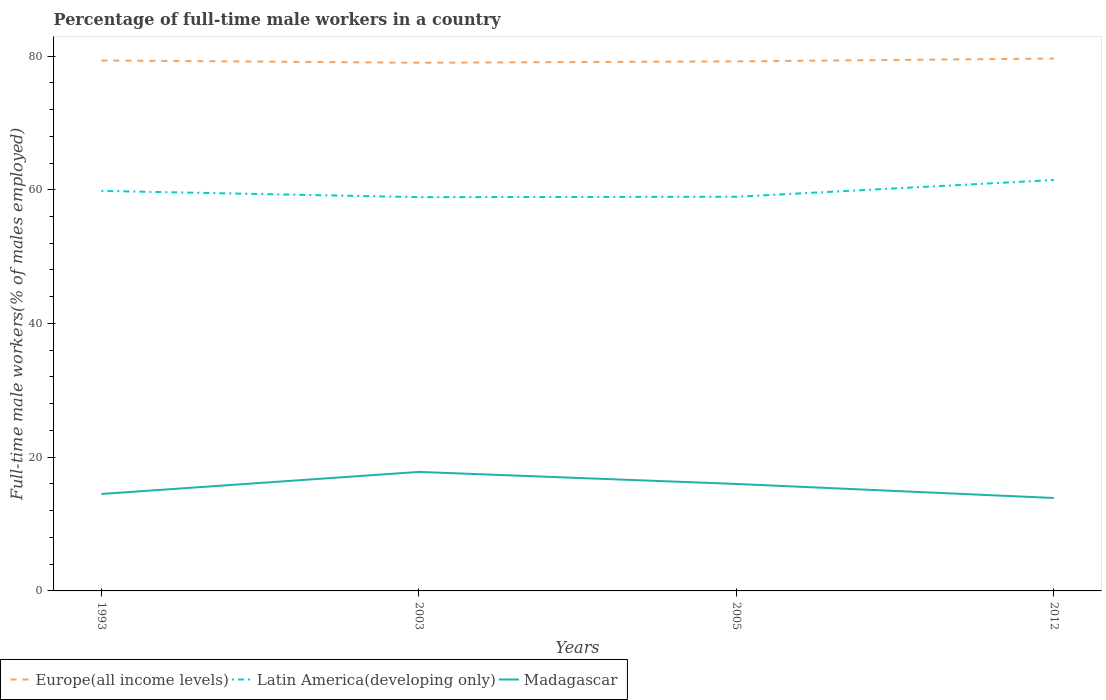How many different coloured lines are there?
Provide a succinct answer. 3. Across all years, what is the maximum percentage of full-time male workers in Europe(all income levels)?
Provide a succinct answer. 79. In which year was the percentage of full-time male workers in Madagascar maximum?
Keep it short and to the point. 2012. What is the total percentage of full-time male workers in Latin America(developing only) in the graph?
Keep it short and to the point. -2.56. What is the difference between the highest and the second highest percentage of full-time male workers in Madagascar?
Give a very brief answer. 3.9. What is the difference between the highest and the lowest percentage of full-time male workers in Europe(all income levels)?
Ensure brevity in your answer.  2. Where does the legend appear in the graph?
Make the answer very short. Bottom left. What is the title of the graph?
Your response must be concise. Percentage of full-time male workers in a country. Does "Vanuatu" appear as one of the legend labels in the graph?
Your answer should be very brief. No. What is the label or title of the X-axis?
Make the answer very short. Years. What is the label or title of the Y-axis?
Your response must be concise. Full-time male workers(% of males employed). What is the Full-time male workers(% of males employed) in Europe(all income levels) in 1993?
Give a very brief answer. 79.34. What is the Full-time male workers(% of males employed) of Latin America(developing only) in 1993?
Ensure brevity in your answer.  59.83. What is the Full-time male workers(% of males employed) of Europe(all income levels) in 2003?
Ensure brevity in your answer.  79. What is the Full-time male workers(% of males employed) of Latin America(developing only) in 2003?
Provide a short and direct response. 58.9. What is the Full-time male workers(% of males employed) of Madagascar in 2003?
Provide a succinct answer. 17.8. What is the Full-time male workers(% of males employed) in Europe(all income levels) in 2005?
Provide a short and direct response. 79.21. What is the Full-time male workers(% of males employed) in Latin America(developing only) in 2005?
Offer a very short reply. 58.95. What is the Full-time male workers(% of males employed) in Madagascar in 2005?
Your response must be concise. 16. What is the Full-time male workers(% of males employed) in Europe(all income levels) in 2012?
Make the answer very short. 79.63. What is the Full-time male workers(% of males employed) in Latin America(developing only) in 2012?
Your answer should be very brief. 61.46. What is the Full-time male workers(% of males employed) of Madagascar in 2012?
Offer a terse response. 13.9. Across all years, what is the maximum Full-time male workers(% of males employed) of Europe(all income levels)?
Your answer should be very brief. 79.63. Across all years, what is the maximum Full-time male workers(% of males employed) of Latin America(developing only)?
Your answer should be compact. 61.46. Across all years, what is the maximum Full-time male workers(% of males employed) of Madagascar?
Your answer should be very brief. 17.8. Across all years, what is the minimum Full-time male workers(% of males employed) in Europe(all income levels)?
Provide a succinct answer. 79. Across all years, what is the minimum Full-time male workers(% of males employed) in Latin America(developing only)?
Offer a terse response. 58.9. Across all years, what is the minimum Full-time male workers(% of males employed) in Madagascar?
Offer a terse response. 13.9. What is the total Full-time male workers(% of males employed) in Europe(all income levels) in the graph?
Your response must be concise. 317.17. What is the total Full-time male workers(% of males employed) in Latin America(developing only) in the graph?
Offer a terse response. 239.14. What is the total Full-time male workers(% of males employed) in Madagascar in the graph?
Provide a succinct answer. 62.2. What is the difference between the Full-time male workers(% of males employed) in Europe(all income levels) in 1993 and that in 2003?
Ensure brevity in your answer.  0.34. What is the difference between the Full-time male workers(% of males employed) of Latin America(developing only) in 1993 and that in 2003?
Provide a short and direct response. 0.93. What is the difference between the Full-time male workers(% of males employed) in Madagascar in 1993 and that in 2003?
Your answer should be compact. -3.3. What is the difference between the Full-time male workers(% of males employed) of Europe(all income levels) in 1993 and that in 2005?
Make the answer very short. 0.13. What is the difference between the Full-time male workers(% of males employed) of Latin America(developing only) in 1993 and that in 2005?
Provide a short and direct response. 0.88. What is the difference between the Full-time male workers(% of males employed) of Madagascar in 1993 and that in 2005?
Ensure brevity in your answer.  -1.5. What is the difference between the Full-time male workers(% of males employed) of Europe(all income levels) in 1993 and that in 2012?
Give a very brief answer. -0.29. What is the difference between the Full-time male workers(% of males employed) of Latin America(developing only) in 1993 and that in 2012?
Give a very brief answer. -1.63. What is the difference between the Full-time male workers(% of males employed) in Europe(all income levels) in 2003 and that in 2005?
Give a very brief answer. -0.21. What is the difference between the Full-time male workers(% of males employed) in Latin America(developing only) in 2003 and that in 2005?
Provide a short and direct response. -0.06. What is the difference between the Full-time male workers(% of males employed) of Madagascar in 2003 and that in 2005?
Give a very brief answer. 1.8. What is the difference between the Full-time male workers(% of males employed) of Europe(all income levels) in 2003 and that in 2012?
Ensure brevity in your answer.  -0.63. What is the difference between the Full-time male workers(% of males employed) in Latin America(developing only) in 2003 and that in 2012?
Provide a succinct answer. -2.56. What is the difference between the Full-time male workers(% of males employed) of Madagascar in 2003 and that in 2012?
Make the answer very short. 3.9. What is the difference between the Full-time male workers(% of males employed) in Europe(all income levels) in 2005 and that in 2012?
Your answer should be compact. -0.42. What is the difference between the Full-time male workers(% of males employed) of Latin America(developing only) in 2005 and that in 2012?
Provide a short and direct response. -2.5. What is the difference between the Full-time male workers(% of males employed) in Madagascar in 2005 and that in 2012?
Provide a succinct answer. 2.1. What is the difference between the Full-time male workers(% of males employed) in Europe(all income levels) in 1993 and the Full-time male workers(% of males employed) in Latin America(developing only) in 2003?
Offer a very short reply. 20.44. What is the difference between the Full-time male workers(% of males employed) of Europe(all income levels) in 1993 and the Full-time male workers(% of males employed) of Madagascar in 2003?
Provide a succinct answer. 61.54. What is the difference between the Full-time male workers(% of males employed) of Latin America(developing only) in 1993 and the Full-time male workers(% of males employed) of Madagascar in 2003?
Your answer should be compact. 42.03. What is the difference between the Full-time male workers(% of males employed) in Europe(all income levels) in 1993 and the Full-time male workers(% of males employed) in Latin America(developing only) in 2005?
Your answer should be compact. 20.39. What is the difference between the Full-time male workers(% of males employed) of Europe(all income levels) in 1993 and the Full-time male workers(% of males employed) of Madagascar in 2005?
Provide a succinct answer. 63.34. What is the difference between the Full-time male workers(% of males employed) in Latin America(developing only) in 1993 and the Full-time male workers(% of males employed) in Madagascar in 2005?
Provide a short and direct response. 43.83. What is the difference between the Full-time male workers(% of males employed) in Europe(all income levels) in 1993 and the Full-time male workers(% of males employed) in Latin America(developing only) in 2012?
Offer a very short reply. 17.88. What is the difference between the Full-time male workers(% of males employed) of Europe(all income levels) in 1993 and the Full-time male workers(% of males employed) of Madagascar in 2012?
Your response must be concise. 65.44. What is the difference between the Full-time male workers(% of males employed) of Latin America(developing only) in 1993 and the Full-time male workers(% of males employed) of Madagascar in 2012?
Your answer should be compact. 45.93. What is the difference between the Full-time male workers(% of males employed) in Europe(all income levels) in 2003 and the Full-time male workers(% of males employed) in Latin America(developing only) in 2005?
Give a very brief answer. 20.04. What is the difference between the Full-time male workers(% of males employed) in Europe(all income levels) in 2003 and the Full-time male workers(% of males employed) in Madagascar in 2005?
Offer a very short reply. 63. What is the difference between the Full-time male workers(% of males employed) of Latin America(developing only) in 2003 and the Full-time male workers(% of males employed) of Madagascar in 2005?
Your answer should be compact. 42.9. What is the difference between the Full-time male workers(% of males employed) in Europe(all income levels) in 2003 and the Full-time male workers(% of males employed) in Latin America(developing only) in 2012?
Provide a short and direct response. 17.54. What is the difference between the Full-time male workers(% of males employed) in Europe(all income levels) in 2003 and the Full-time male workers(% of males employed) in Madagascar in 2012?
Offer a very short reply. 65.1. What is the difference between the Full-time male workers(% of males employed) of Latin America(developing only) in 2003 and the Full-time male workers(% of males employed) of Madagascar in 2012?
Ensure brevity in your answer.  45. What is the difference between the Full-time male workers(% of males employed) in Europe(all income levels) in 2005 and the Full-time male workers(% of males employed) in Latin America(developing only) in 2012?
Offer a terse response. 17.75. What is the difference between the Full-time male workers(% of males employed) in Europe(all income levels) in 2005 and the Full-time male workers(% of males employed) in Madagascar in 2012?
Your answer should be compact. 65.31. What is the difference between the Full-time male workers(% of males employed) of Latin America(developing only) in 2005 and the Full-time male workers(% of males employed) of Madagascar in 2012?
Provide a succinct answer. 45.05. What is the average Full-time male workers(% of males employed) in Europe(all income levels) per year?
Your response must be concise. 79.29. What is the average Full-time male workers(% of males employed) of Latin America(developing only) per year?
Offer a very short reply. 59.78. What is the average Full-time male workers(% of males employed) in Madagascar per year?
Provide a short and direct response. 15.55. In the year 1993, what is the difference between the Full-time male workers(% of males employed) of Europe(all income levels) and Full-time male workers(% of males employed) of Latin America(developing only)?
Your response must be concise. 19.51. In the year 1993, what is the difference between the Full-time male workers(% of males employed) of Europe(all income levels) and Full-time male workers(% of males employed) of Madagascar?
Provide a succinct answer. 64.84. In the year 1993, what is the difference between the Full-time male workers(% of males employed) of Latin America(developing only) and Full-time male workers(% of males employed) of Madagascar?
Ensure brevity in your answer.  45.33. In the year 2003, what is the difference between the Full-time male workers(% of males employed) in Europe(all income levels) and Full-time male workers(% of males employed) in Latin America(developing only)?
Provide a succinct answer. 20.1. In the year 2003, what is the difference between the Full-time male workers(% of males employed) in Europe(all income levels) and Full-time male workers(% of males employed) in Madagascar?
Your answer should be very brief. 61.2. In the year 2003, what is the difference between the Full-time male workers(% of males employed) in Latin America(developing only) and Full-time male workers(% of males employed) in Madagascar?
Your response must be concise. 41.1. In the year 2005, what is the difference between the Full-time male workers(% of males employed) of Europe(all income levels) and Full-time male workers(% of males employed) of Latin America(developing only)?
Your response must be concise. 20.25. In the year 2005, what is the difference between the Full-time male workers(% of males employed) of Europe(all income levels) and Full-time male workers(% of males employed) of Madagascar?
Your response must be concise. 63.21. In the year 2005, what is the difference between the Full-time male workers(% of males employed) of Latin America(developing only) and Full-time male workers(% of males employed) of Madagascar?
Provide a short and direct response. 42.95. In the year 2012, what is the difference between the Full-time male workers(% of males employed) in Europe(all income levels) and Full-time male workers(% of males employed) in Latin America(developing only)?
Ensure brevity in your answer.  18.17. In the year 2012, what is the difference between the Full-time male workers(% of males employed) in Europe(all income levels) and Full-time male workers(% of males employed) in Madagascar?
Your answer should be very brief. 65.73. In the year 2012, what is the difference between the Full-time male workers(% of males employed) in Latin America(developing only) and Full-time male workers(% of males employed) in Madagascar?
Keep it short and to the point. 47.56. What is the ratio of the Full-time male workers(% of males employed) of Latin America(developing only) in 1993 to that in 2003?
Your answer should be compact. 1.02. What is the ratio of the Full-time male workers(% of males employed) of Madagascar in 1993 to that in 2003?
Provide a short and direct response. 0.81. What is the ratio of the Full-time male workers(% of males employed) in Europe(all income levels) in 1993 to that in 2005?
Keep it short and to the point. 1. What is the ratio of the Full-time male workers(% of males employed) of Latin America(developing only) in 1993 to that in 2005?
Your answer should be compact. 1.01. What is the ratio of the Full-time male workers(% of males employed) in Madagascar in 1993 to that in 2005?
Keep it short and to the point. 0.91. What is the ratio of the Full-time male workers(% of males employed) of Europe(all income levels) in 1993 to that in 2012?
Your answer should be very brief. 1. What is the ratio of the Full-time male workers(% of males employed) in Latin America(developing only) in 1993 to that in 2012?
Keep it short and to the point. 0.97. What is the ratio of the Full-time male workers(% of males employed) in Madagascar in 1993 to that in 2012?
Offer a very short reply. 1.04. What is the ratio of the Full-time male workers(% of males employed) in Madagascar in 2003 to that in 2005?
Your response must be concise. 1.11. What is the ratio of the Full-time male workers(% of males employed) of Europe(all income levels) in 2003 to that in 2012?
Offer a very short reply. 0.99. What is the ratio of the Full-time male workers(% of males employed) of Madagascar in 2003 to that in 2012?
Your answer should be very brief. 1.28. What is the ratio of the Full-time male workers(% of males employed) of Latin America(developing only) in 2005 to that in 2012?
Make the answer very short. 0.96. What is the ratio of the Full-time male workers(% of males employed) in Madagascar in 2005 to that in 2012?
Your answer should be compact. 1.15. What is the difference between the highest and the second highest Full-time male workers(% of males employed) of Europe(all income levels)?
Offer a very short reply. 0.29. What is the difference between the highest and the second highest Full-time male workers(% of males employed) of Latin America(developing only)?
Your response must be concise. 1.63. What is the difference between the highest and the second highest Full-time male workers(% of males employed) in Madagascar?
Provide a succinct answer. 1.8. What is the difference between the highest and the lowest Full-time male workers(% of males employed) in Europe(all income levels)?
Your response must be concise. 0.63. What is the difference between the highest and the lowest Full-time male workers(% of males employed) in Latin America(developing only)?
Make the answer very short. 2.56. 